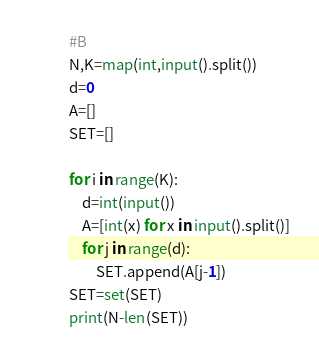Convert code to text. <code><loc_0><loc_0><loc_500><loc_500><_Python_>#B
N,K=map(int,input().split())
d=0
A=[]
SET=[]

for i in range(K):
    d=int(input())
    A=[int(x) for x in input().split()]
    for j in range(d):
        SET.append(A[j-1])
SET=set(SET)    
print(N-len(SET))</code> 